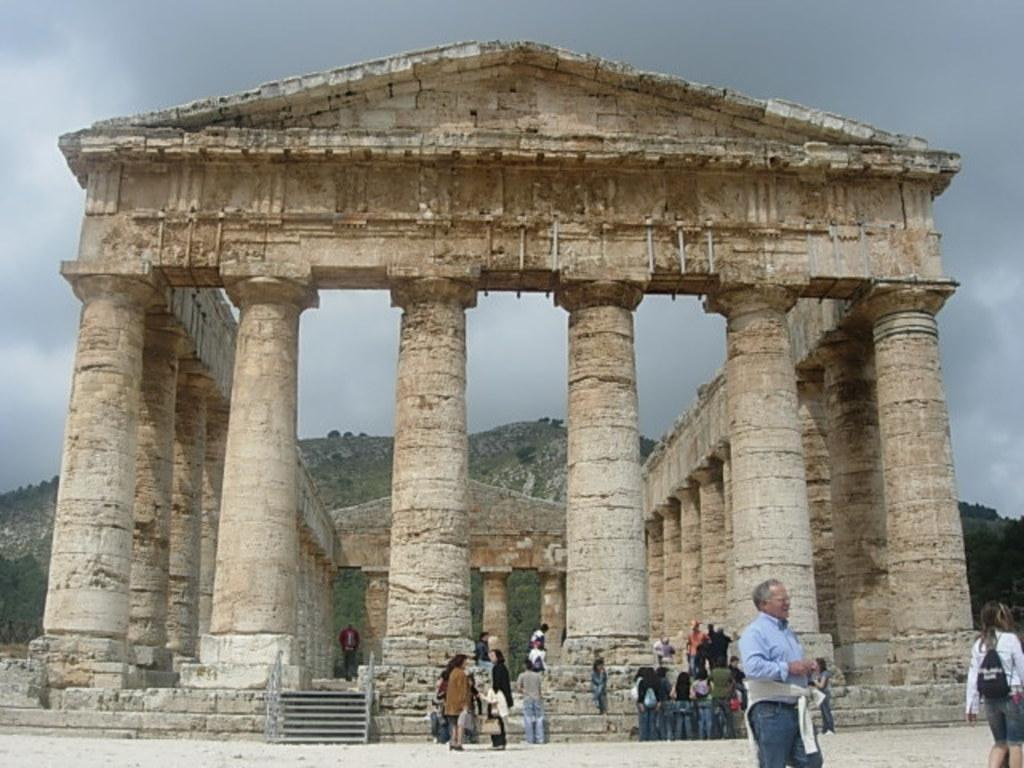What type of structure is present in the image? There is an ancient building with pillars in the image. What else can be seen in the image besides the ancient building? There are groups of people standing in the image. What can be seen in the background of the image? Hills and the sky are visible in the background of the image. How many drawers are visible in the image? There are no drawers present in the image. What type of transport is being used by the people in the image? The image does not show any form of transport being used by the people. 